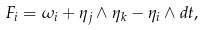Convert formula to latex. <formula><loc_0><loc_0><loc_500><loc_500>F _ { i } = \omega _ { i } + \eta _ { j } \wedge \eta _ { k } - \eta _ { i } \wedge d t ,</formula> 